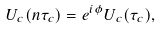<formula> <loc_0><loc_0><loc_500><loc_500>U _ { c } ( n \tau _ { c } ) = e ^ { i \phi } U _ { c } ( \tau _ { c } ) ,</formula> 